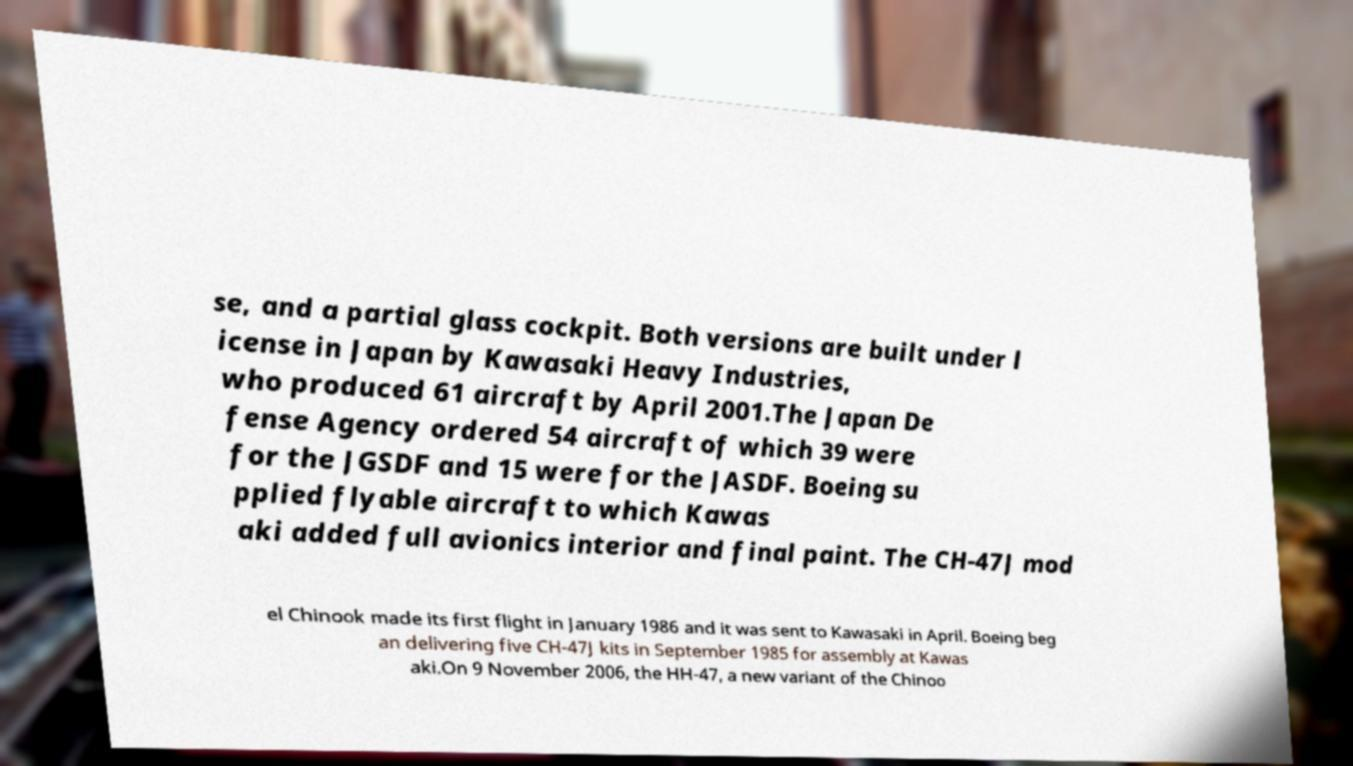Please read and relay the text visible in this image. What does it say? se, and a partial glass cockpit. Both versions are built under l icense in Japan by Kawasaki Heavy Industries, who produced 61 aircraft by April 2001.The Japan De fense Agency ordered 54 aircraft of which 39 were for the JGSDF and 15 were for the JASDF. Boeing su pplied flyable aircraft to which Kawas aki added full avionics interior and final paint. The CH-47J mod el Chinook made its first flight in January 1986 and it was sent to Kawasaki in April. Boeing beg an delivering five CH-47J kits in September 1985 for assembly at Kawas aki.On 9 November 2006, the HH-47, a new variant of the Chinoo 